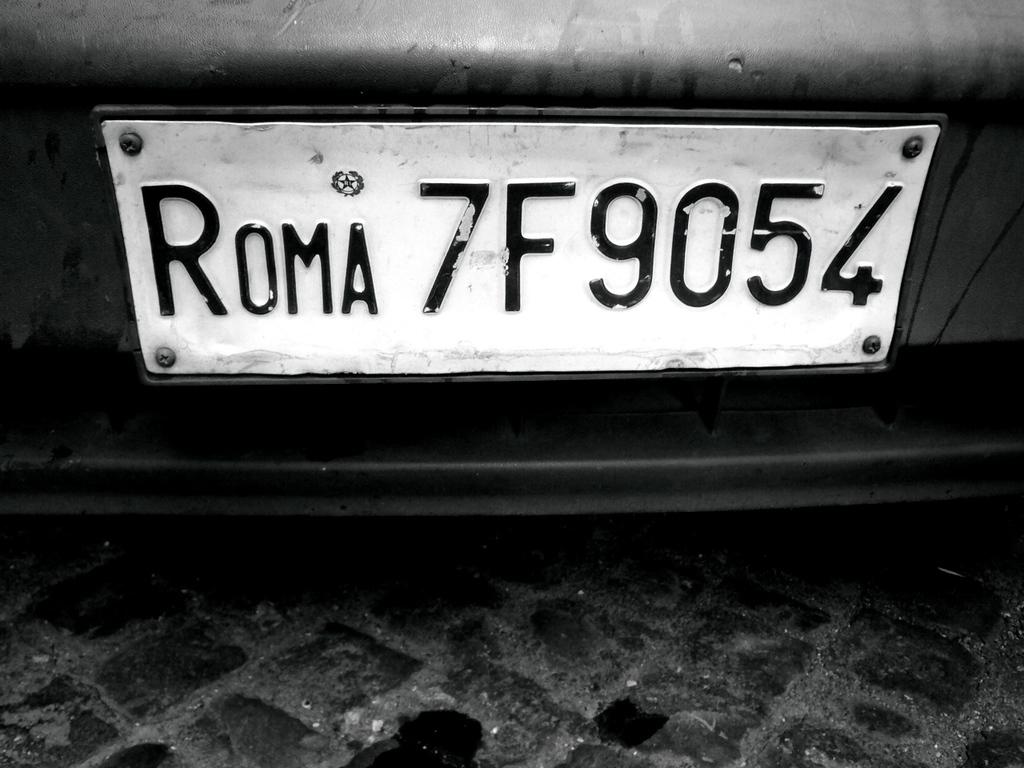What is the license plate number?
Provide a succinct answer. 7f9054. What is the word before the number on the license plate?
Provide a succinct answer. Roma. 